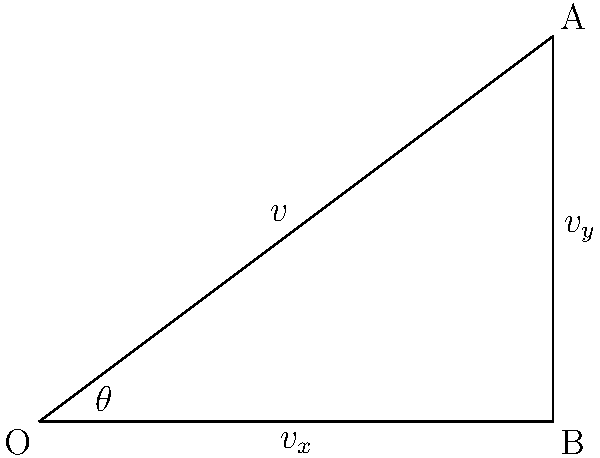A long-range missile is launched with an initial velocity $v$ of 800 m/s at an angle $\theta$ of 36.87° above the horizontal. Calculate the horizontal ($v_x$) and vertical ($v_y$) components of the missile's initial velocity vector. To solve this problem, we need to use vector decomposition and trigonometric functions. Here's a step-by-step approach:

1) The horizontal component $v_x$ is calculated using the cosine of the angle:
   $$v_x = v \cos(\theta)$$

2) The vertical component $v_y$ is calculated using the sine of the angle:
   $$v_y = v \sin(\theta)$$

3) Given:
   - Initial velocity $v = 800$ m/s
   - Angle $\theta = 36.87°$

4) Calculate $v_x$:
   $$v_x = 800 \cos(36.87°) = 800 \times 0.8 = 640$$ m/s

5) Calculate $v_y$:
   $$v_y = 800 \sin(36.87°) = 800 \times 0.6 = 480$$ m/s

Therefore, the horizontal component of the missile's initial velocity is 640 m/s, and the vertical component is 480 m/s.
Answer: $v_x = 640$ m/s, $v_y = 480$ m/s 